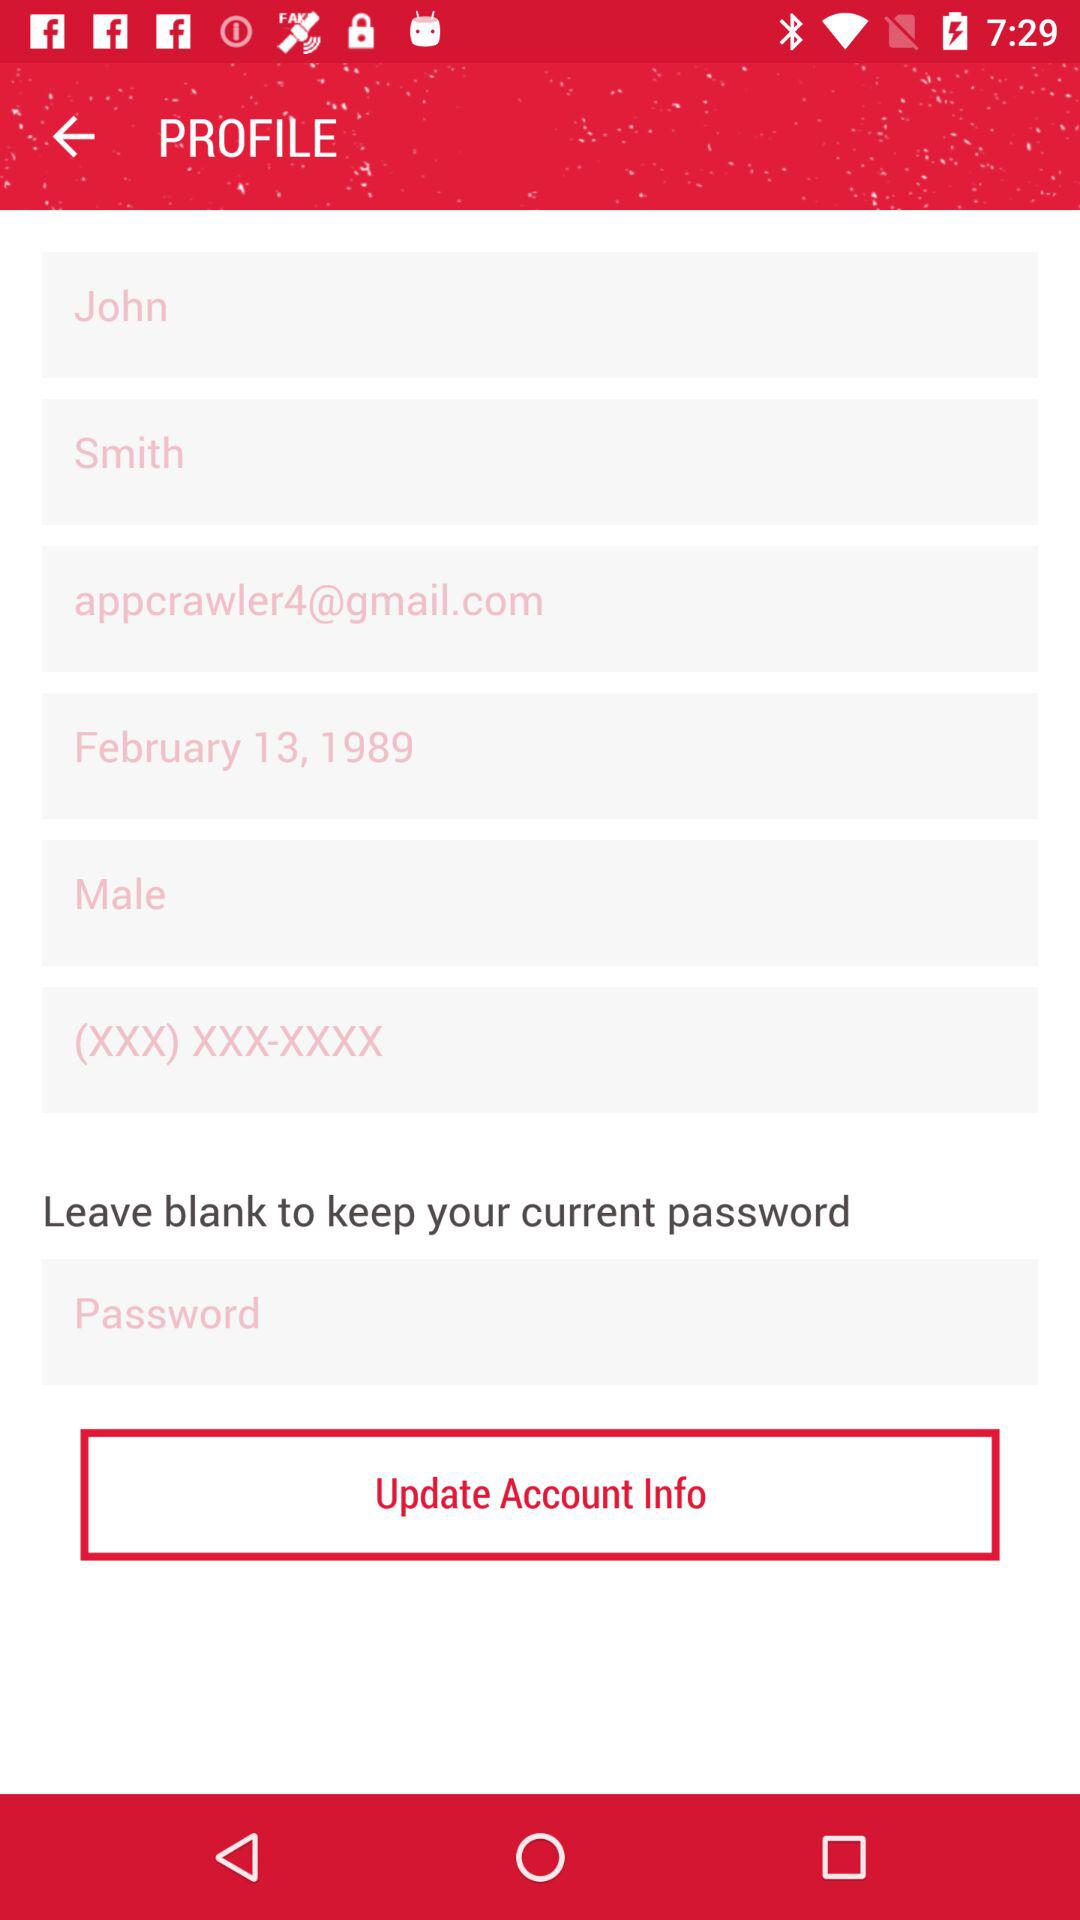What is the email address of John? The email address is appcrawler4@gmail.com. 